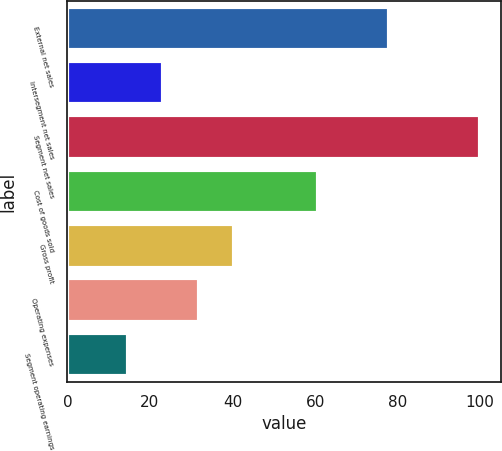Convert chart. <chart><loc_0><loc_0><loc_500><loc_500><bar_chart><fcel>External net sales<fcel>Intersegment net sales<fcel>Segment net sales<fcel>Cost of goods sold<fcel>Gross profit<fcel>Operating expenses<fcel>Segment operating earnings<nl><fcel>78<fcel>23.23<fcel>100<fcel>60.6<fcel>40.29<fcel>31.76<fcel>14.7<nl></chart> 